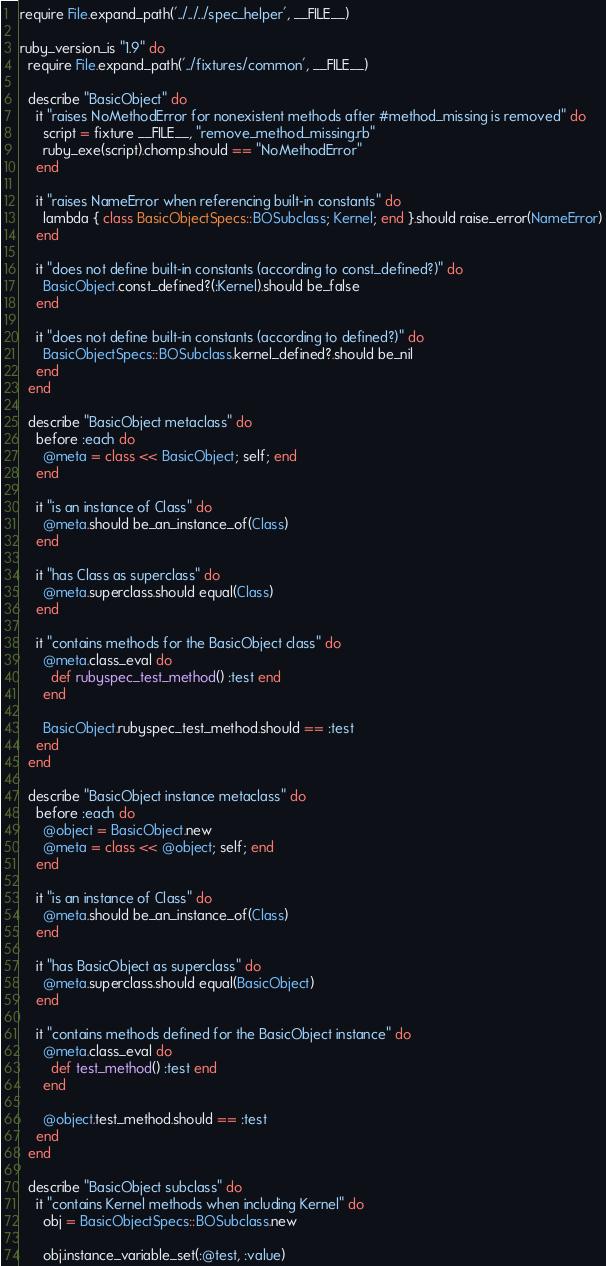<code> <loc_0><loc_0><loc_500><loc_500><_Ruby_>require File.expand_path('../../../spec_helper', __FILE__)

ruby_version_is "1.9" do
  require File.expand_path('../fixtures/common', __FILE__)

  describe "BasicObject" do
    it "raises NoMethodError for nonexistent methods after #method_missing is removed" do
      script = fixture __FILE__, "remove_method_missing.rb"
      ruby_exe(script).chomp.should == "NoMethodError"
    end

    it "raises NameError when referencing built-in constants" do
      lambda { class BasicObjectSpecs::BOSubclass; Kernel; end }.should raise_error(NameError)
    end

    it "does not define built-in constants (according to const_defined?)" do
      BasicObject.const_defined?(:Kernel).should be_false
    end

    it "does not define built-in constants (according to defined?)" do
      BasicObjectSpecs::BOSubclass.kernel_defined?.should be_nil
    end
  end

  describe "BasicObject metaclass" do
    before :each do
      @meta = class << BasicObject; self; end
    end

    it "is an instance of Class" do
      @meta.should be_an_instance_of(Class)
    end

    it "has Class as superclass" do
      @meta.superclass.should equal(Class)
    end

    it "contains methods for the BasicObject class" do
      @meta.class_eval do
        def rubyspec_test_method() :test end
      end

      BasicObject.rubyspec_test_method.should == :test
    end
  end

  describe "BasicObject instance metaclass" do
    before :each do
      @object = BasicObject.new
      @meta = class << @object; self; end
    end

    it "is an instance of Class" do
      @meta.should be_an_instance_of(Class)
    end

    it "has BasicObject as superclass" do
      @meta.superclass.should equal(BasicObject)
    end

    it "contains methods defined for the BasicObject instance" do
      @meta.class_eval do
        def test_method() :test end
      end

      @object.test_method.should == :test
    end
  end

  describe "BasicObject subclass" do
    it "contains Kernel methods when including Kernel" do
      obj = BasicObjectSpecs::BOSubclass.new

      obj.instance_variable_set(:@test, :value)</code> 